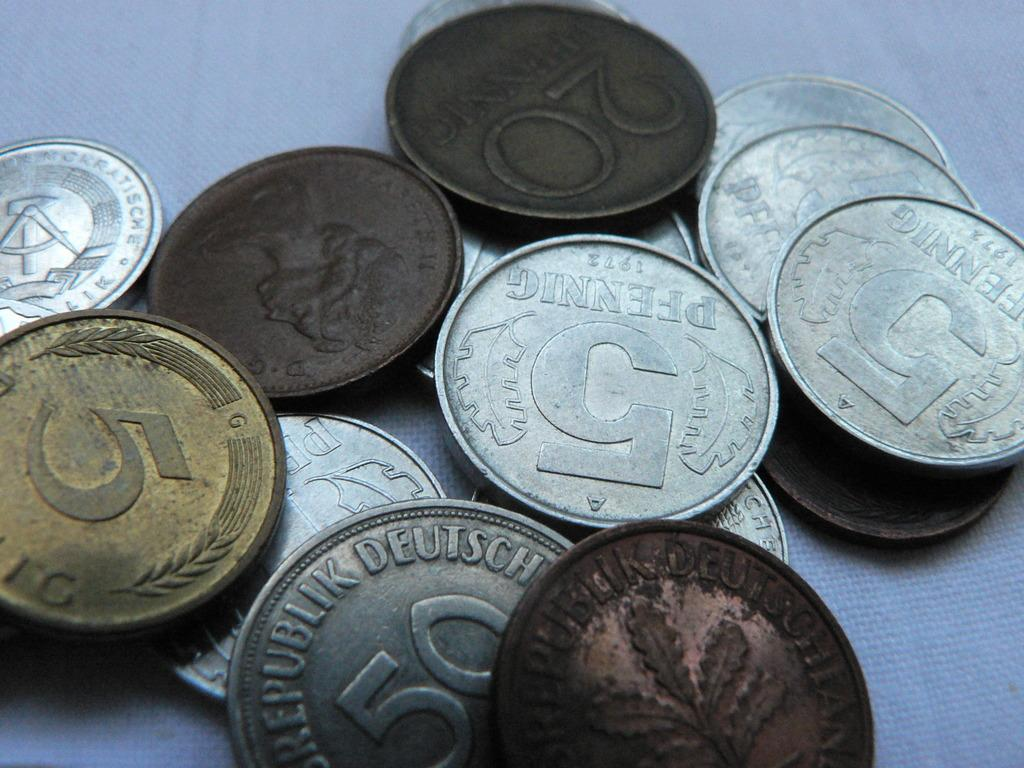Provide a one-sentence caption for the provided image. The coin collection was worthless in the United States. 